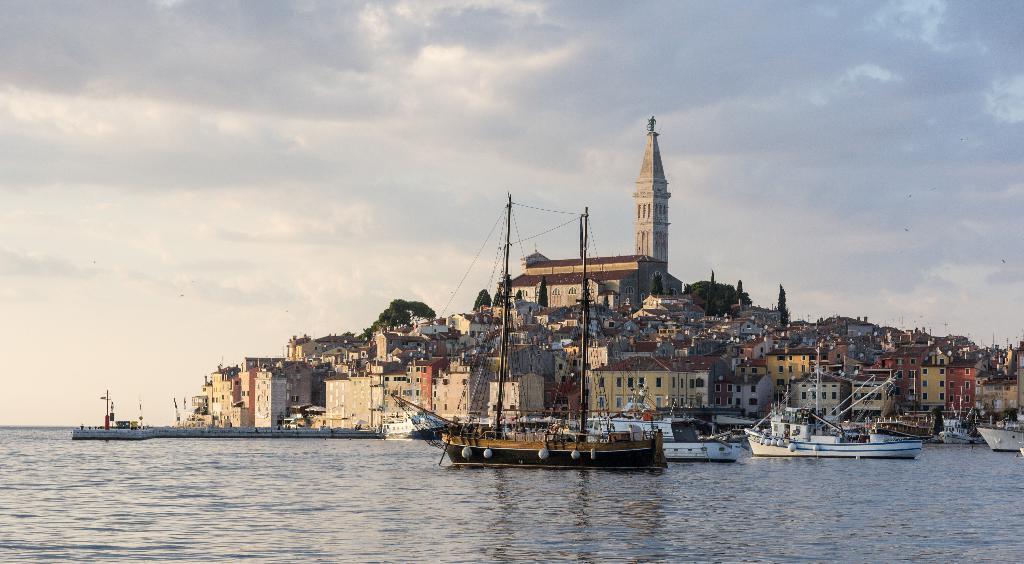Please provide a concise description of this image. In this image few boats are sailing on the water. There are few buildings, trees and a tower are on the land. Top of image there is sky. 